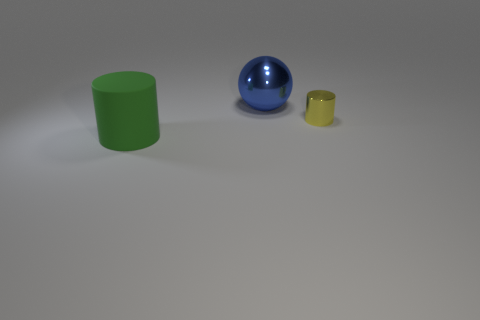What is the size of the object that is both on the left side of the tiny yellow metal cylinder and in front of the sphere?
Your answer should be very brief. Large. Is there a cylinder in front of the thing that is to the right of the large sphere?
Offer a terse response. Yes. The yellow thing has what size?
Provide a short and direct response. Small. What number of objects are brown metallic things or large green matte objects?
Ensure brevity in your answer.  1. Do the cylinder in front of the yellow shiny cylinder and the large thing that is on the right side of the green matte thing have the same material?
Offer a very short reply. No. What is the color of the cylinder that is the same material as the blue thing?
Provide a short and direct response. Yellow. How many matte cylinders are the same size as the metallic sphere?
Ensure brevity in your answer.  1. What number of other objects are the same color as the big rubber thing?
Your answer should be very brief. 0. Are there any other things that are the same size as the blue object?
Keep it short and to the point. Yes. Do the metal object in front of the big blue ball and the metal object behind the tiny metallic cylinder have the same shape?
Give a very brief answer. No. 